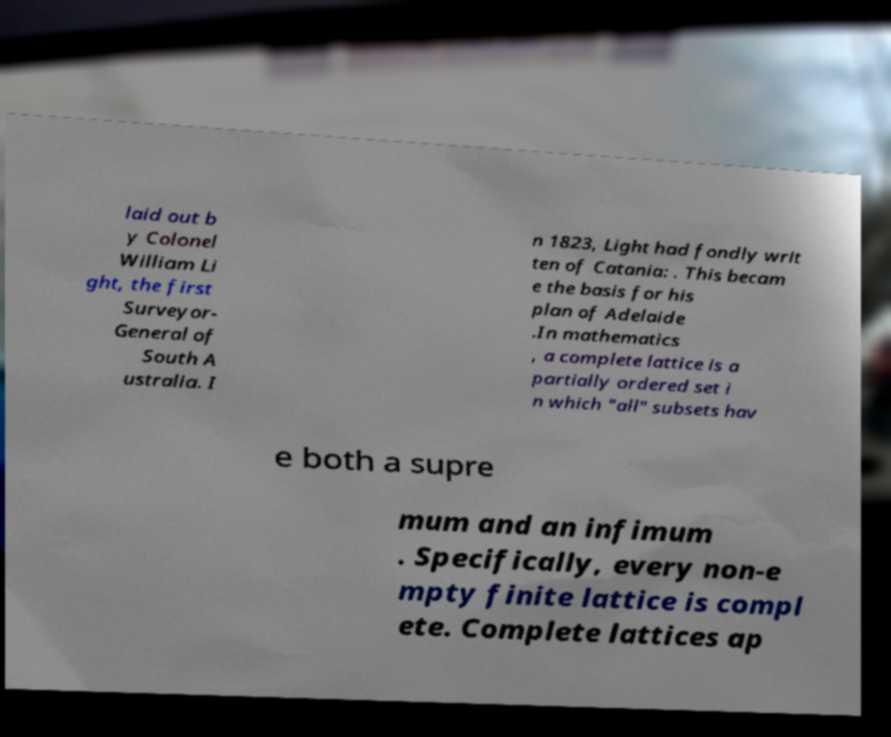There's text embedded in this image that I need extracted. Can you transcribe it verbatim? laid out b y Colonel William Li ght, the first Surveyor- General of South A ustralia. I n 1823, Light had fondly writ ten of Catania: . This becam e the basis for his plan of Adelaide .In mathematics , a complete lattice is a partially ordered set i n which "all" subsets hav e both a supre mum and an infimum . Specifically, every non-e mpty finite lattice is compl ete. Complete lattices ap 